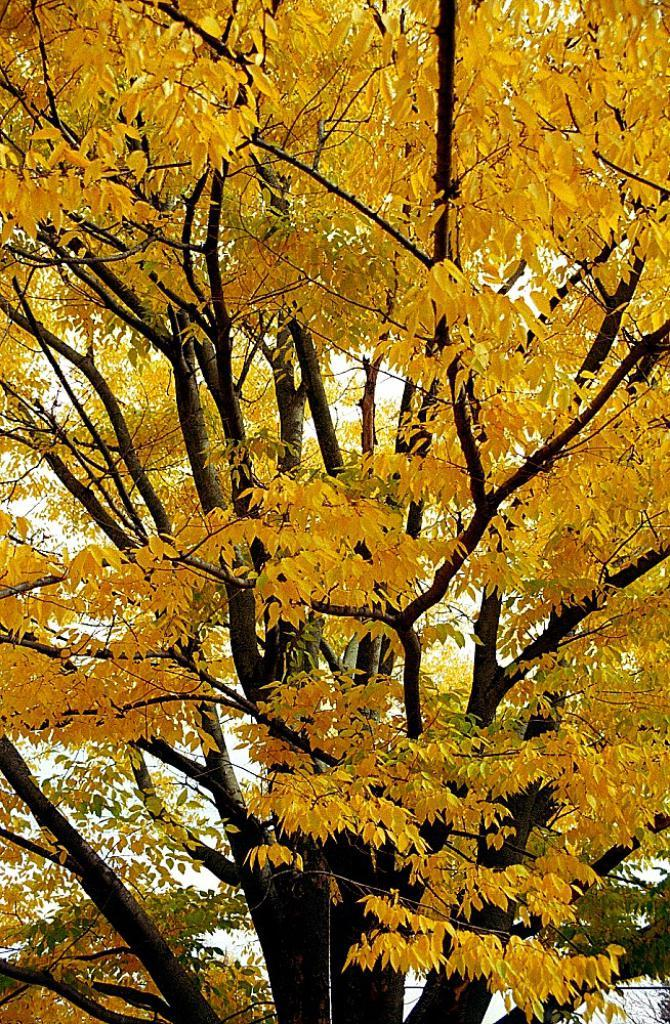What type of plant can be seen in the image? There is a tree in the image. What colors are the leaves on the tree? Some leaves on the tree are yellow in color, while others are green in color. What type of crack is visible in the image? There is no crack present in the image; it features a tree with yellow and green leaves. What scene is depicted in the image? The image depicts a tree with yellow and green leaves, but it does not show a specific scene or event. 